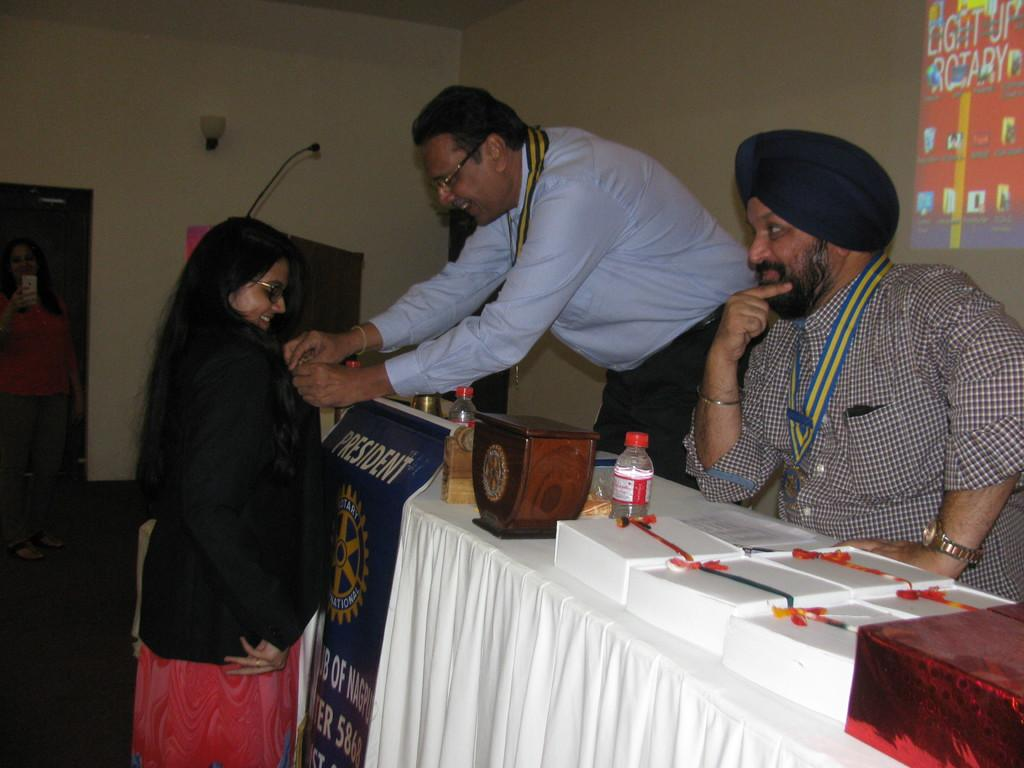<image>
Relay a brief, clear account of the picture shown. A man giving a woman a badge in front of a sign which says PRESIDENT. 